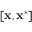Convert formula to latex. <formula><loc_0><loc_0><loc_500><loc_500>[ x , x ^ { * } ]</formula> 